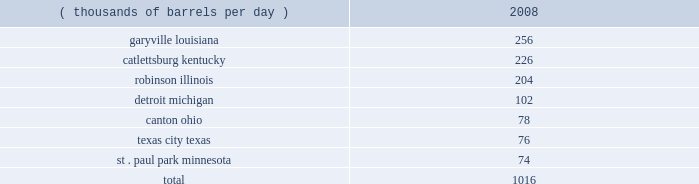Our refineries processed 944 mbpd of crude oil and 207 mbpd of other charge and blend stocks .
The table below sets forth the location and daily crude oil refining capacity of each of our refineries as of december 31 , 2008 .
Crude oil refining capacity ( thousands of barrels per day ) 2008 .
Our refineries include crude oil atmospheric and vacuum distillation , fluid catalytic cracking , catalytic reforming , desulfurization and sulfur recovery units .
The refineries process a wide variety of crude oils and produce numerous refined products , ranging from transportation fuels , such as reformulated gasolines , blend- grade gasolines intended for blending with fuel ethanol and ultra-low sulfur diesel fuel , to heavy fuel oil and asphalt .
Additionally , we manufacture aromatics , cumene , propane , propylene , sulfur and maleic anhydride .
Our refineries are integrated with each other via pipelines , terminals and barges to maximize operating efficiency .
The transportation links that connect our refineries allow the movement of intermediate products between refineries to optimize operations , produce higher margin products and utilize our processing capacity efficiently .
Our garyville , louisiana , refinery is located along the mississippi river in southeastern louisiana .
The garyville refinery processes heavy sour crude oil into products such as gasoline , distillates , sulfur , asphalt , propane , polymer grade propylene , isobutane and coke .
In 2006 , we approved an expansion of our garyville refinery by 180 mbpd to 436 mbpd , with a currently projected cost of $ 3.35 billion ( excluding capitalized interest ) .
Construction commenced in early 2007 and is continuing on schedule .
We estimate that , as of december 31 , 2008 , this project is approximately 75 percent complete .
We expect to complete the expansion in late 2009 .
Our catlettsburg , kentucky , refinery is located in northeastern kentucky on the western bank of the big sandy river , near the confluence with the ohio river .
The catlettsburg refinery processes sweet and sour crude oils into products such as gasoline , asphalt , diesel , jet fuel , petrochemicals , propane , propylene and sulfur .
Our robinson , illinois , refinery is located in the southeastern illinois town of robinson .
The robinson refinery processes sweet and sour crude oils into products such as multiple grades of gasoline , jet fuel , kerosene , diesel fuel , propane , propylene , sulfur and anode-grade coke .
Our detroit , michigan , refinery is located near interstate 75 in southwest detroit .
The detroit refinery processes light sweet and heavy sour crude oils , including canadian crude oils , into products such as gasoline , diesel , asphalt , slurry , propane , chemical grade propylene and sulfur .
In 2007 , we approved a heavy oil upgrading and expansion project at our detroit , michigan , refinery , with a current projected cost of $ 2.2 billion ( excluding capitalized interest ) .
This project will enable the refinery to process additional heavy sour crude oils , including canadian bitumen blends , and will increase its crude oil refining capacity by about 15 percent .
Construction began in the first half of 2008 and is presently expected to be complete in mid-2012 .
Our canton , ohio , refinery is located approximately 60 miles southeast of cleveland , ohio .
The canton refinery processes sweet and sour crude oils into products such as gasoline , diesel fuels , kerosene , propane , sulfur , asphalt , roofing flux , home heating oil and no .
6 industrial fuel oil .
Our texas city , texas , refinery is located on the texas gulf coast approximately 30 miles south of houston , texas .
The refinery processes sweet crude oil into products such as gasoline , propane , chemical grade propylene , slurry , sulfur and aromatics .
Our st .
Paul park , minnesota , refinery is located in st .
Paul park , a suburb of minneapolis-st .
Paul .
The st .
Paul park refinery processes predominantly canadian crude oils into products such as gasoline , diesel , jet fuel , kerosene , asphalt , propane , propylene and sulfur. .
What percentage of crude oil refining capacity is located in detroit michigan? 
Computations: (102 / 1016)
Answer: 0.10039. 